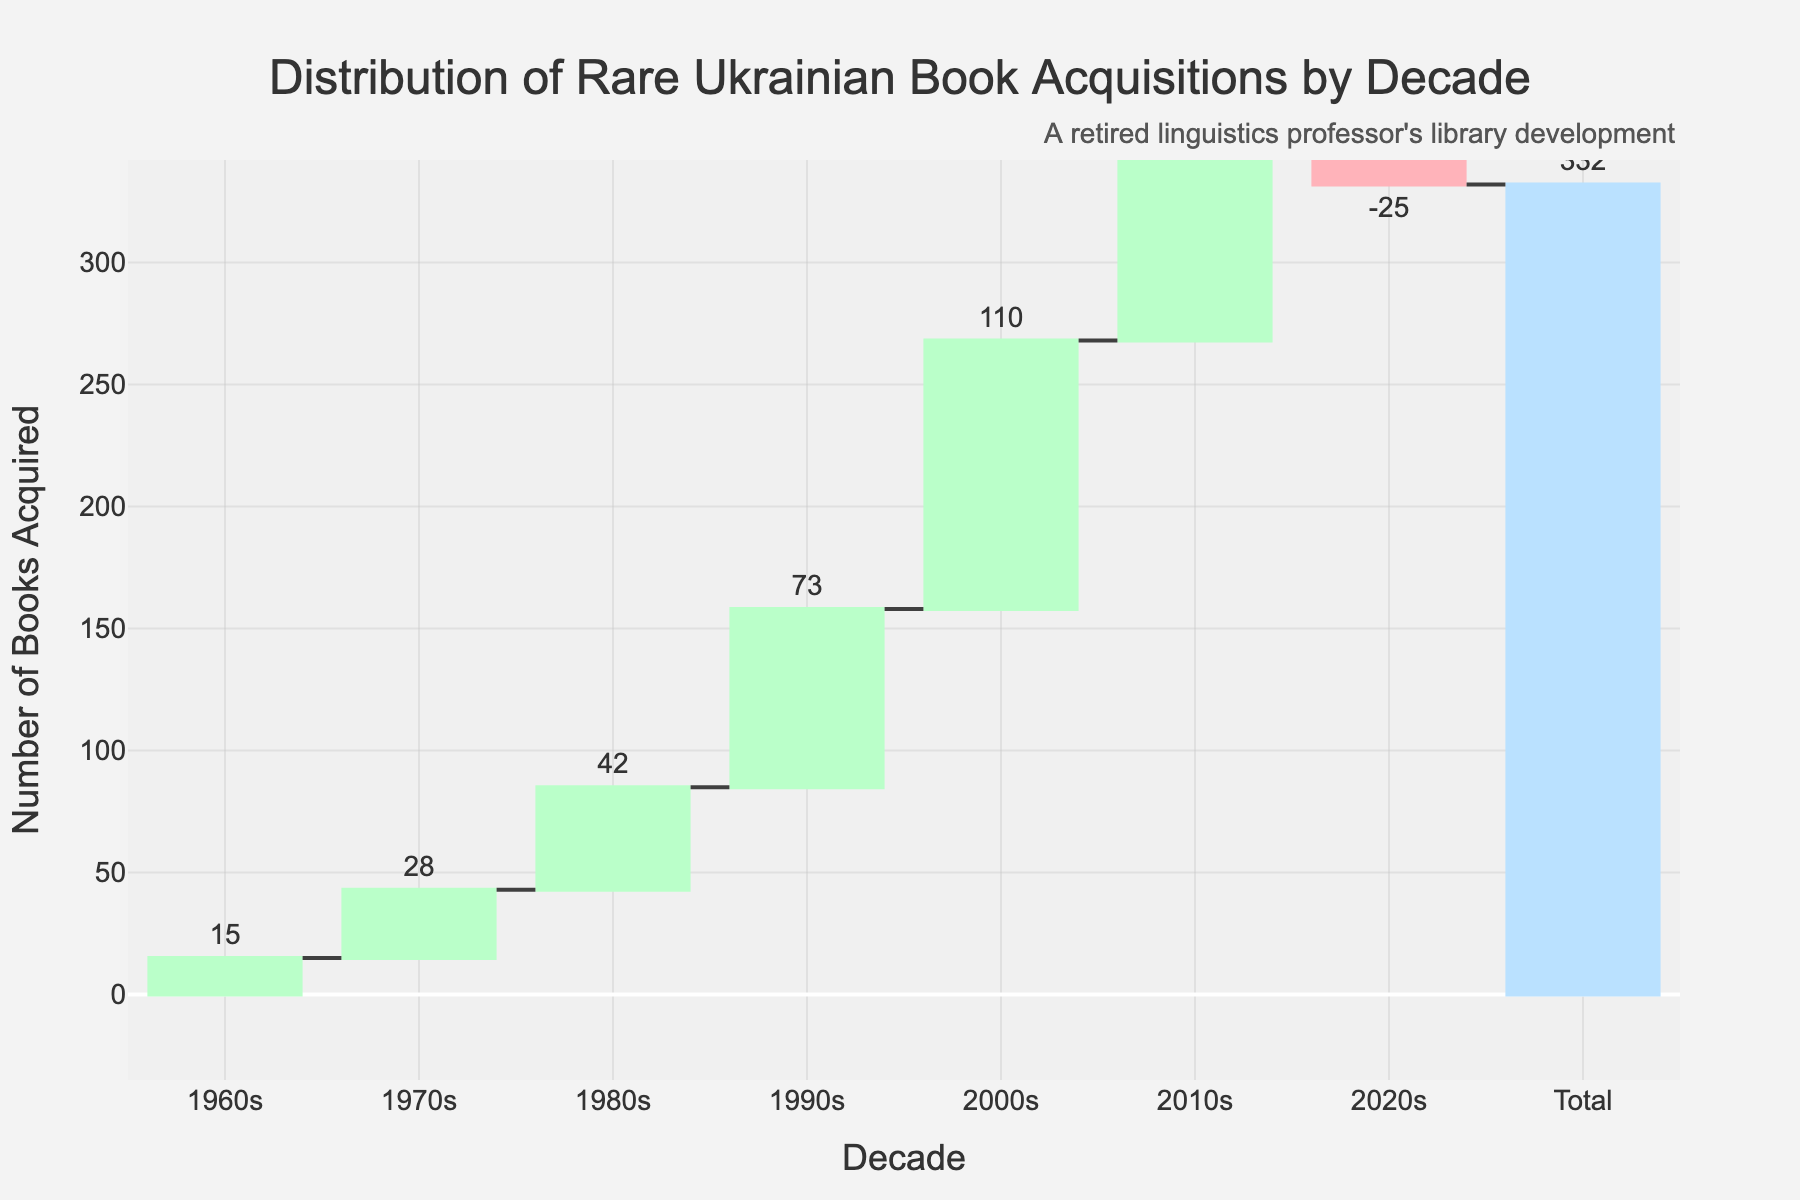What is the title of the chart? The title is often found at the top of the chart and it is: "Distribution of Rare Ukrainian Book Acquisitions by Decade"
Answer: Distribution of Rare Ukrainian Book Acquisitions by Decade How many books were acquired in the 1990s? Locate the bar corresponding to the 1990s on the x-axis; the text indicates the number of books acquired: 73
Answer: 73 What was the total number of books acquired by 2020s? The "Total" bar at the end of the chart shows the cumulative total acquisitions across all decades, which is 332
Answer: 332 Which decade had the highest number of books acquired? Compare the heights of the bars; the bar for the 2000s is the tallest, indicating 110 books were acquired then
Answer: 2000s How many more books were acquired in the 2000s compared to the 2010s? Subtract the number of books acquired in the 2010s (89) from the number in the 2000s (110): 110 - 89 = 21
Answer: 21 What is the significance of the color coding in the chart? Observe the colors used: green indicates increasing acquisitions, red indicates a decrease (2020s), and blue indicates the total.
Answer: Different phases of acquisitions Why does the 2020s column show a negative number? The negative value indicates a reduction in the number of books, likely due to deaccession or removal of books
Answer: Deaccession or removal of books From which decade did the acquisitions start accelerating the most? Compare the rate of increase; notable acceleration happens between 1980s and 1990s (a jump from 42 to 73)
Answer: Between 1980s and 1990s What was the cumulative number of books acquired by the end of the 1990s? Sum the books from 1960s to 1990s: 15 + 28 + 42 + 73 = 158
Answer: 158 How do the acquisitions in the 1960s compare to the total number? The first bar (15 books in the 1960s) is a small fraction of the total cumulative bar (332)
Answer: Small fraction, 15/332 